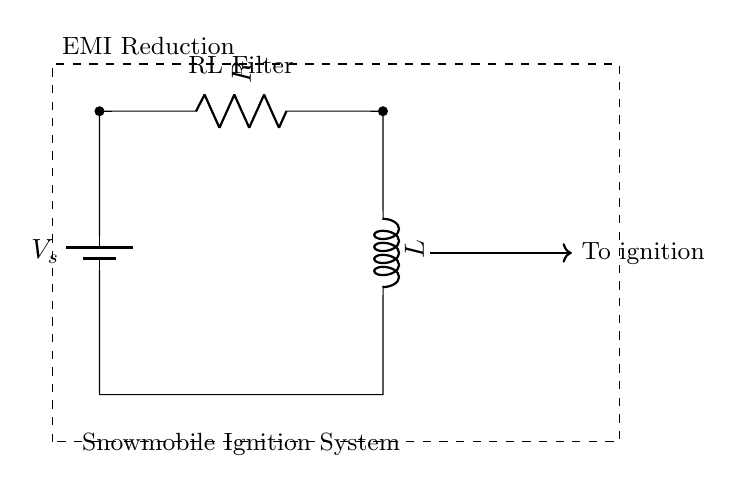What components are in the circuit? The circuit contains a battery, a resistor, and an inductor, which are the basic components used to form the RL filter.
Answer: battery, resistor, inductor What does the R in this circuit represent? The R represents a resistor, which is a component that limits the flow of current in the circuit.
Answer: resistor What is the purpose of the RL filter shown? The RL filter is used to reduce electromagnetic interference in the ignition system of the snowmobile by smoothing out the electrical signals.
Answer: EMI Reduction How does the inductor affect the circuit? The inductor in the circuit stores energy in a magnetic field when current flows through it, helping to filter high-frequency noise, thus improving the stability of the ignition system.
Answer: Smoothing current What is the direction of current flow in this circuit? The current flows from the battery through the resistor, then through the inductor, and back to the battery, indicating a complete loop in the circuit.
Answer: Clockwise How does the resistor affect voltage drop in the circuit? The resistor causes a voltage drop proportional to the current passing through it according to Ohm's law, helping to manage the voltage applied to other components like the inductor.
Answer: Limits voltage 